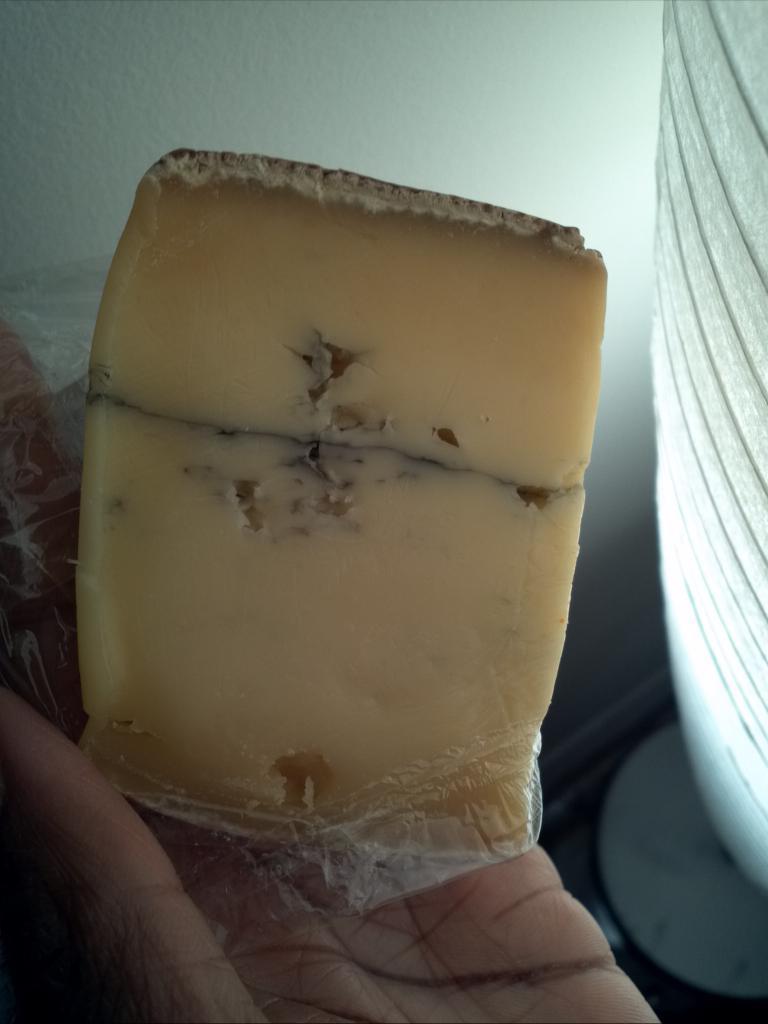How would you summarize this image in a sentence or two? In this image I can see the person holding some object and the object is in cream color. Background the wall is in white color. 